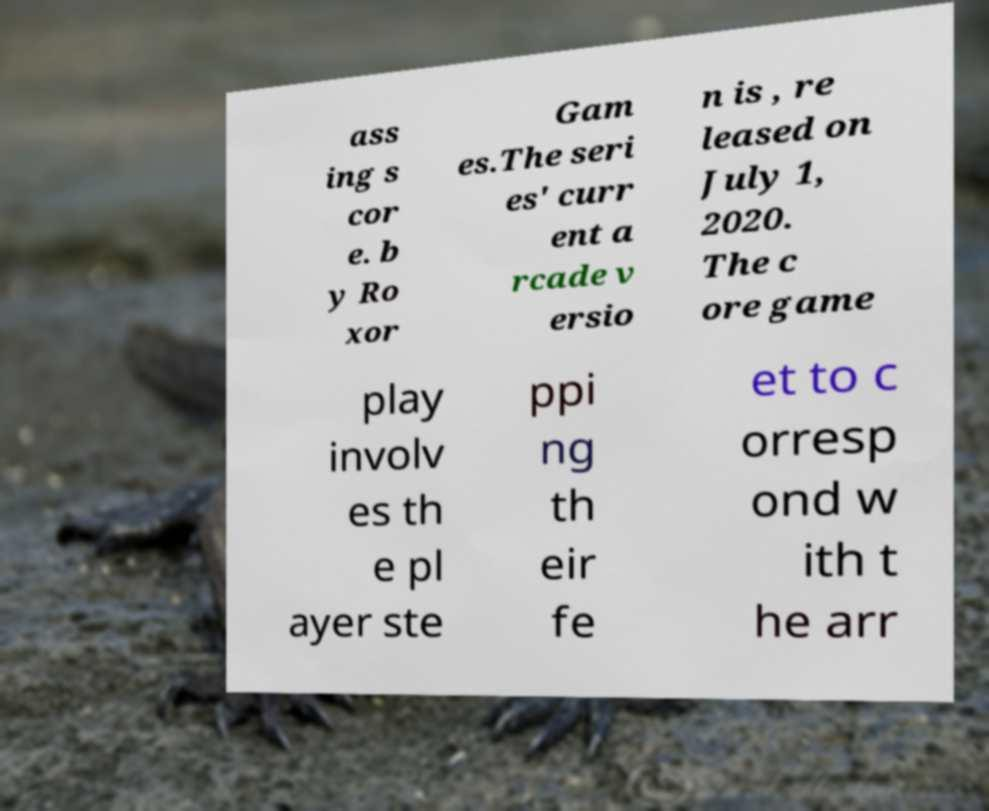There's text embedded in this image that I need extracted. Can you transcribe it verbatim? ass ing s cor e. b y Ro xor Gam es.The seri es' curr ent a rcade v ersio n is , re leased on July 1, 2020. The c ore game play involv es th e pl ayer ste ppi ng th eir fe et to c orresp ond w ith t he arr 